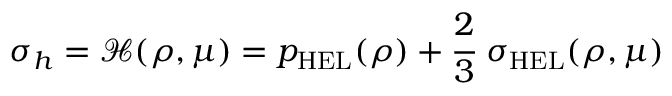Convert formula to latex. <formula><loc_0><loc_0><loc_500><loc_500>\sigma _ { h } = { \mathcal { H } } ( \rho , \mu ) = p _ { H E L } ( \rho ) + { \cfrac { 2 } { 3 } } \sigma _ { H E L } ( \rho , \mu )</formula> 